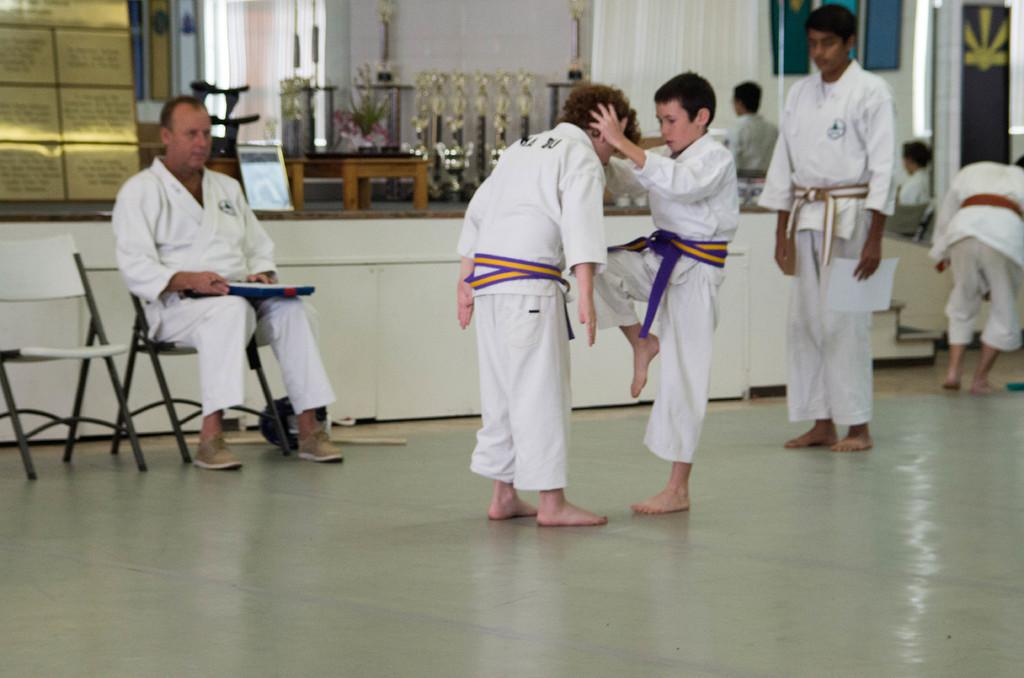What are the children doing in the image? The children are practicing kung fu in the image. Who is the person sitting on a table in the image? There is a master sitting on a table in the image. What is the master doing in the image? The master is examining something in the image. Where are the children and the master located in the image? The children and the master are on the left side of the image. What page of the book is the beetle reading in the image? There is no beetle or book present in the image. 